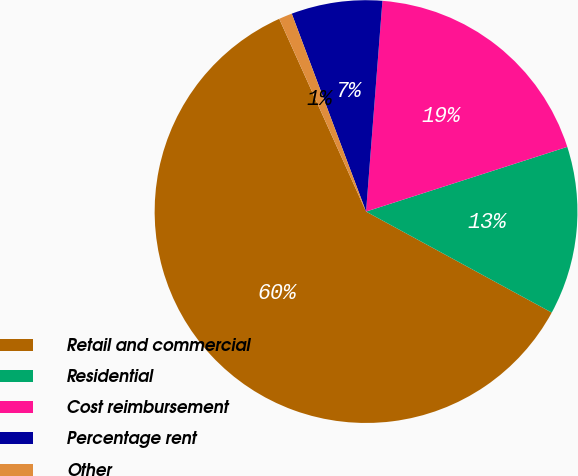Convert chart to OTSL. <chart><loc_0><loc_0><loc_500><loc_500><pie_chart><fcel>Retail and commercial<fcel>Residential<fcel>Cost reimbursement<fcel>Percentage rent<fcel>Other<nl><fcel>60.33%<fcel>12.88%<fcel>18.81%<fcel>6.95%<fcel>1.02%<nl></chart> 